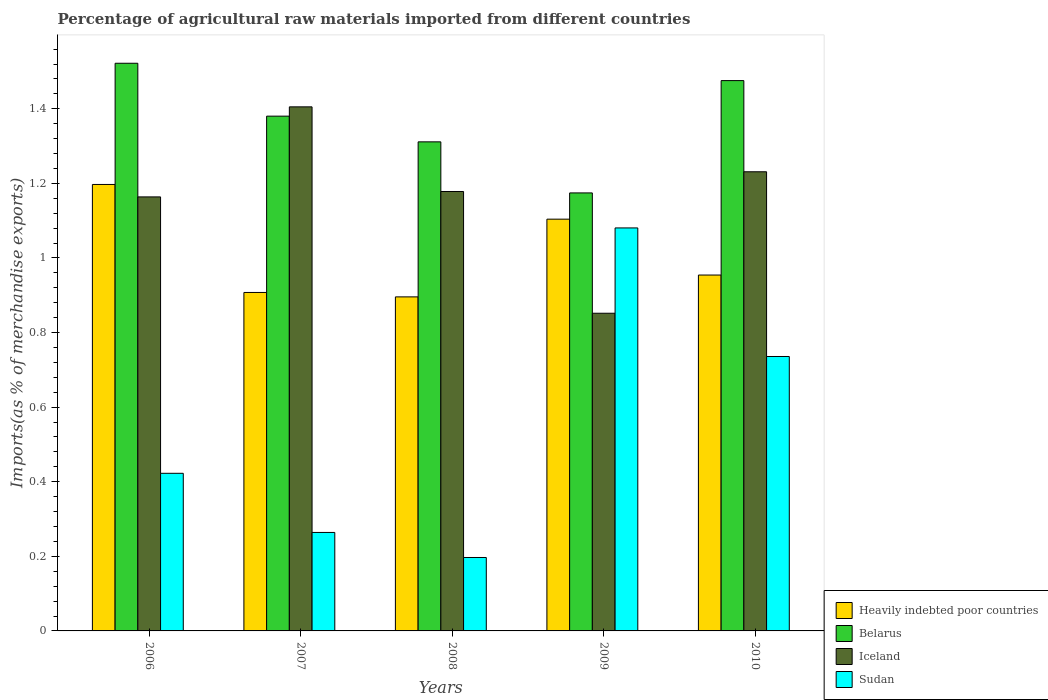How many groups of bars are there?
Offer a terse response. 5. Are the number of bars per tick equal to the number of legend labels?
Give a very brief answer. Yes. Are the number of bars on each tick of the X-axis equal?
Your response must be concise. Yes. How many bars are there on the 2nd tick from the left?
Your answer should be compact. 4. What is the percentage of imports to different countries in Sudan in 2007?
Your answer should be very brief. 0.26. Across all years, what is the maximum percentage of imports to different countries in Sudan?
Give a very brief answer. 1.08. Across all years, what is the minimum percentage of imports to different countries in Sudan?
Give a very brief answer. 0.2. In which year was the percentage of imports to different countries in Sudan maximum?
Provide a short and direct response. 2009. What is the total percentage of imports to different countries in Iceland in the graph?
Keep it short and to the point. 5.83. What is the difference between the percentage of imports to different countries in Belarus in 2006 and that in 2009?
Provide a succinct answer. 0.35. What is the difference between the percentage of imports to different countries in Belarus in 2007 and the percentage of imports to different countries in Iceland in 2006?
Provide a short and direct response. 0.22. What is the average percentage of imports to different countries in Belarus per year?
Provide a short and direct response. 1.37. In the year 2009, what is the difference between the percentage of imports to different countries in Belarus and percentage of imports to different countries in Heavily indebted poor countries?
Offer a very short reply. 0.07. What is the ratio of the percentage of imports to different countries in Belarus in 2008 to that in 2009?
Provide a short and direct response. 1.12. Is the difference between the percentage of imports to different countries in Belarus in 2007 and 2009 greater than the difference between the percentage of imports to different countries in Heavily indebted poor countries in 2007 and 2009?
Ensure brevity in your answer.  Yes. What is the difference between the highest and the second highest percentage of imports to different countries in Iceland?
Give a very brief answer. 0.17. What is the difference between the highest and the lowest percentage of imports to different countries in Sudan?
Keep it short and to the point. 0.88. In how many years, is the percentage of imports to different countries in Sudan greater than the average percentage of imports to different countries in Sudan taken over all years?
Offer a very short reply. 2. Is the sum of the percentage of imports to different countries in Heavily indebted poor countries in 2008 and 2009 greater than the maximum percentage of imports to different countries in Sudan across all years?
Keep it short and to the point. Yes. Is it the case that in every year, the sum of the percentage of imports to different countries in Belarus and percentage of imports to different countries in Iceland is greater than the sum of percentage of imports to different countries in Heavily indebted poor countries and percentage of imports to different countries in Sudan?
Your answer should be very brief. Yes. What does the 2nd bar from the left in 2008 represents?
Your answer should be very brief. Belarus. What does the 4th bar from the right in 2009 represents?
Your answer should be compact. Heavily indebted poor countries. How many years are there in the graph?
Provide a short and direct response. 5. What is the difference between two consecutive major ticks on the Y-axis?
Keep it short and to the point. 0.2. Does the graph contain any zero values?
Provide a succinct answer. No. How many legend labels are there?
Give a very brief answer. 4. How are the legend labels stacked?
Provide a short and direct response. Vertical. What is the title of the graph?
Keep it short and to the point. Percentage of agricultural raw materials imported from different countries. Does "Kyrgyz Republic" appear as one of the legend labels in the graph?
Your answer should be compact. No. What is the label or title of the X-axis?
Your response must be concise. Years. What is the label or title of the Y-axis?
Provide a succinct answer. Imports(as % of merchandise exports). What is the Imports(as % of merchandise exports) of Heavily indebted poor countries in 2006?
Your response must be concise. 1.2. What is the Imports(as % of merchandise exports) of Belarus in 2006?
Make the answer very short. 1.52. What is the Imports(as % of merchandise exports) of Iceland in 2006?
Provide a short and direct response. 1.16. What is the Imports(as % of merchandise exports) of Sudan in 2006?
Ensure brevity in your answer.  0.42. What is the Imports(as % of merchandise exports) in Heavily indebted poor countries in 2007?
Ensure brevity in your answer.  0.91. What is the Imports(as % of merchandise exports) of Belarus in 2007?
Keep it short and to the point. 1.38. What is the Imports(as % of merchandise exports) in Iceland in 2007?
Give a very brief answer. 1.41. What is the Imports(as % of merchandise exports) in Sudan in 2007?
Ensure brevity in your answer.  0.26. What is the Imports(as % of merchandise exports) in Heavily indebted poor countries in 2008?
Keep it short and to the point. 0.9. What is the Imports(as % of merchandise exports) in Belarus in 2008?
Provide a short and direct response. 1.31. What is the Imports(as % of merchandise exports) of Iceland in 2008?
Offer a terse response. 1.18. What is the Imports(as % of merchandise exports) in Sudan in 2008?
Your answer should be compact. 0.2. What is the Imports(as % of merchandise exports) of Heavily indebted poor countries in 2009?
Your answer should be very brief. 1.1. What is the Imports(as % of merchandise exports) in Belarus in 2009?
Your response must be concise. 1.17. What is the Imports(as % of merchandise exports) of Iceland in 2009?
Give a very brief answer. 0.85. What is the Imports(as % of merchandise exports) of Sudan in 2009?
Your response must be concise. 1.08. What is the Imports(as % of merchandise exports) of Heavily indebted poor countries in 2010?
Offer a terse response. 0.95. What is the Imports(as % of merchandise exports) of Belarus in 2010?
Offer a very short reply. 1.48. What is the Imports(as % of merchandise exports) of Iceland in 2010?
Provide a succinct answer. 1.23. What is the Imports(as % of merchandise exports) of Sudan in 2010?
Keep it short and to the point. 0.74. Across all years, what is the maximum Imports(as % of merchandise exports) in Heavily indebted poor countries?
Offer a very short reply. 1.2. Across all years, what is the maximum Imports(as % of merchandise exports) in Belarus?
Your response must be concise. 1.52. Across all years, what is the maximum Imports(as % of merchandise exports) of Iceland?
Your answer should be very brief. 1.41. Across all years, what is the maximum Imports(as % of merchandise exports) in Sudan?
Offer a very short reply. 1.08. Across all years, what is the minimum Imports(as % of merchandise exports) in Heavily indebted poor countries?
Ensure brevity in your answer.  0.9. Across all years, what is the minimum Imports(as % of merchandise exports) of Belarus?
Your answer should be very brief. 1.17. Across all years, what is the minimum Imports(as % of merchandise exports) of Iceland?
Give a very brief answer. 0.85. Across all years, what is the minimum Imports(as % of merchandise exports) in Sudan?
Give a very brief answer. 0.2. What is the total Imports(as % of merchandise exports) of Heavily indebted poor countries in the graph?
Provide a succinct answer. 5.06. What is the total Imports(as % of merchandise exports) of Belarus in the graph?
Give a very brief answer. 6.86. What is the total Imports(as % of merchandise exports) of Iceland in the graph?
Give a very brief answer. 5.83. What is the total Imports(as % of merchandise exports) in Sudan in the graph?
Provide a short and direct response. 2.7. What is the difference between the Imports(as % of merchandise exports) of Heavily indebted poor countries in 2006 and that in 2007?
Your response must be concise. 0.29. What is the difference between the Imports(as % of merchandise exports) in Belarus in 2006 and that in 2007?
Offer a very short reply. 0.14. What is the difference between the Imports(as % of merchandise exports) of Iceland in 2006 and that in 2007?
Ensure brevity in your answer.  -0.24. What is the difference between the Imports(as % of merchandise exports) in Sudan in 2006 and that in 2007?
Your answer should be very brief. 0.16. What is the difference between the Imports(as % of merchandise exports) in Heavily indebted poor countries in 2006 and that in 2008?
Your answer should be compact. 0.3. What is the difference between the Imports(as % of merchandise exports) in Belarus in 2006 and that in 2008?
Offer a terse response. 0.21. What is the difference between the Imports(as % of merchandise exports) in Iceland in 2006 and that in 2008?
Make the answer very short. -0.01. What is the difference between the Imports(as % of merchandise exports) of Sudan in 2006 and that in 2008?
Your response must be concise. 0.23. What is the difference between the Imports(as % of merchandise exports) of Heavily indebted poor countries in 2006 and that in 2009?
Your answer should be very brief. 0.09. What is the difference between the Imports(as % of merchandise exports) in Belarus in 2006 and that in 2009?
Your answer should be compact. 0.35. What is the difference between the Imports(as % of merchandise exports) of Iceland in 2006 and that in 2009?
Give a very brief answer. 0.31. What is the difference between the Imports(as % of merchandise exports) in Sudan in 2006 and that in 2009?
Ensure brevity in your answer.  -0.66. What is the difference between the Imports(as % of merchandise exports) of Heavily indebted poor countries in 2006 and that in 2010?
Ensure brevity in your answer.  0.24. What is the difference between the Imports(as % of merchandise exports) in Belarus in 2006 and that in 2010?
Your response must be concise. 0.05. What is the difference between the Imports(as % of merchandise exports) in Iceland in 2006 and that in 2010?
Make the answer very short. -0.07. What is the difference between the Imports(as % of merchandise exports) of Sudan in 2006 and that in 2010?
Ensure brevity in your answer.  -0.31. What is the difference between the Imports(as % of merchandise exports) of Heavily indebted poor countries in 2007 and that in 2008?
Provide a short and direct response. 0.01. What is the difference between the Imports(as % of merchandise exports) in Belarus in 2007 and that in 2008?
Keep it short and to the point. 0.07. What is the difference between the Imports(as % of merchandise exports) of Iceland in 2007 and that in 2008?
Make the answer very short. 0.23. What is the difference between the Imports(as % of merchandise exports) of Sudan in 2007 and that in 2008?
Provide a short and direct response. 0.07. What is the difference between the Imports(as % of merchandise exports) in Heavily indebted poor countries in 2007 and that in 2009?
Ensure brevity in your answer.  -0.2. What is the difference between the Imports(as % of merchandise exports) in Belarus in 2007 and that in 2009?
Provide a short and direct response. 0.21. What is the difference between the Imports(as % of merchandise exports) of Iceland in 2007 and that in 2009?
Your answer should be very brief. 0.55. What is the difference between the Imports(as % of merchandise exports) in Sudan in 2007 and that in 2009?
Your response must be concise. -0.82. What is the difference between the Imports(as % of merchandise exports) of Heavily indebted poor countries in 2007 and that in 2010?
Ensure brevity in your answer.  -0.05. What is the difference between the Imports(as % of merchandise exports) of Belarus in 2007 and that in 2010?
Your answer should be compact. -0.1. What is the difference between the Imports(as % of merchandise exports) of Iceland in 2007 and that in 2010?
Make the answer very short. 0.17. What is the difference between the Imports(as % of merchandise exports) of Sudan in 2007 and that in 2010?
Offer a terse response. -0.47. What is the difference between the Imports(as % of merchandise exports) of Heavily indebted poor countries in 2008 and that in 2009?
Offer a terse response. -0.21. What is the difference between the Imports(as % of merchandise exports) in Belarus in 2008 and that in 2009?
Provide a short and direct response. 0.14. What is the difference between the Imports(as % of merchandise exports) in Iceland in 2008 and that in 2009?
Keep it short and to the point. 0.33. What is the difference between the Imports(as % of merchandise exports) of Sudan in 2008 and that in 2009?
Make the answer very short. -0.88. What is the difference between the Imports(as % of merchandise exports) in Heavily indebted poor countries in 2008 and that in 2010?
Provide a succinct answer. -0.06. What is the difference between the Imports(as % of merchandise exports) in Belarus in 2008 and that in 2010?
Ensure brevity in your answer.  -0.16. What is the difference between the Imports(as % of merchandise exports) of Iceland in 2008 and that in 2010?
Offer a terse response. -0.05. What is the difference between the Imports(as % of merchandise exports) in Sudan in 2008 and that in 2010?
Make the answer very short. -0.54. What is the difference between the Imports(as % of merchandise exports) of Heavily indebted poor countries in 2009 and that in 2010?
Provide a short and direct response. 0.15. What is the difference between the Imports(as % of merchandise exports) in Belarus in 2009 and that in 2010?
Your response must be concise. -0.3. What is the difference between the Imports(as % of merchandise exports) of Iceland in 2009 and that in 2010?
Your response must be concise. -0.38. What is the difference between the Imports(as % of merchandise exports) of Sudan in 2009 and that in 2010?
Provide a succinct answer. 0.34. What is the difference between the Imports(as % of merchandise exports) of Heavily indebted poor countries in 2006 and the Imports(as % of merchandise exports) of Belarus in 2007?
Keep it short and to the point. -0.18. What is the difference between the Imports(as % of merchandise exports) in Heavily indebted poor countries in 2006 and the Imports(as % of merchandise exports) in Iceland in 2007?
Your answer should be compact. -0.21. What is the difference between the Imports(as % of merchandise exports) of Heavily indebted poor countries in 2006 and the Imports(as % of merchandise exports) of Sudan in 2007?
Provide a short and direct response. 0.93. What is the difference between the Imports(as % of merchandise exports) of Belarus in 2006 and the Imports(as % of merchandise exports) of Iceland in 2007?
Your response must be concise. 0.12. What is the difference between the Imports(as % of merchandise exports) of Belarus in 2006 and the Imports(as % of merchandise exports) of Sudan in 2007?
Give a very brief answer. 1.26. What is the difference between the Imports(as % of merchandise exports) of Iceland in 2006 and the Imports(as % of merchandise exports) of Sudan in 2007?
Make the answer very short. 0.9. What is the difference between the Imports(as % of merchandise exports) of Heavily indebted poor countries in 2006 and the Imports(as % of merchandise exports) of Belarus in 2008?
Make the answer very short. -0.11. What is the difference between the Imports(as % of merchandise exports) in Heavily indebted poor countries in 2006 and the Imports(as % of merchandise exports) in Iceland in 2008?
Your answer should be compact. 0.02. What is the difference between the Imports(as % of merchandise exports) in Belarus in 2006 and the Imports(as % of merchandise exports) in Iceland in 2008?
Provide a succinct answer. 0.34. What is the difference between the Imports(as % of merchandise exports) in Belarus in 2006 and the Imports(as % of merchandise exports) in Sudan in 2008?
Provide a succinct answer. 1.33. What is the difference between the Imports(as % of merchandise exports) in Iceland in 2006 and the Imports(as % of merchandise exports) in Sudan in 2008?
Your response must be concise. 0.97. What is the difference between the Imports(as % of merchandise exports) in Heavily indebted poor countries in 2006 and the Imports(as % of merchandise exports) in Belarus in 2009?
Your response must be concise. 0.02. What is the difference between the Imports(as % of merchandise exports) of Heavily indebted poor countries in 2006 and the Imports(as % of merchandise exports) of Iceland in 2009?
Provide a succinct answer. 0.35. What is the difference between the Imports(as % of merchandise exports) in Heavily indebted poor countries in 2006 and the Imports(as % of merchandise exports) in Sudan in 2009?
Keep it short and to the point. 0.12. What is the difference between the Imports(as % of merchandise exports) of Belarus in 2006 and the Imports(as % of merchandise exports) of Iceland in 2009?
Provide a succinct answer. 0.67. What is the difference between the Imports(as % of merchandise exports) of Belarus in 2006 and the Imports(as % of merchandise exports) of Sudan in 2009?
Your response must be concise. 0.44. What is the difference between the Imports(as % of merchandise exports) of Iceland in 2006 and the Imports(as % of merchandise exports) of Sudan in 2009?
Provide a short and direct response. 0.08. What is the difference between the Imports(as % of merchandise exports) in Heavily indebted poor countries in 2006 and the Imports(as % of merchandise exports) in Belarus in 2010?
Make the answer very short. -0.28. What is the difference between the Imports(as % of merchandise exports) of Heavily indebted poor countries in 2006 and the Imports(as % of merchandise exports) of Iceland in 2010?
Make the answer very short. -0.03. What is the difference between the Imports(as % of merchandise exports) in Heavily indebted poor countries in 2006 and the Imports(as % of merchandise exports) in Sudan in 2010?
Your answer should be compact. 0.46. What is the difference between the Imports(as % of merchandise exports) in Belarus in 2006 and the Imports(as % of merchandise exports) in Iceland in 2010?
Ensure brevity in your answer.  0.29. What is the difference between the Imports(as % of merchandise exports) of Belarus in 2006 and the Imports(as % of merchandise exports) of Sudan in 2010?
Your response must be concise. 0.79. What is the difference between the Imports(as % of merchandise exports) in Iceland in 2006 and the Imports(as % of merchandise exports) in Sudan in 2010?
Your response must be concise. 0.43. What is the difference between the Imports(as % of merchandise exports) in Heavily indebted poor countries in 2007 and the Imports(as % of merchandise exports) in Belarus in 2008?
Make the answer very short. -0.4. What is the difference between the Imports(as % of merchandise exports) in Heavily indebted poor countries in 2007 and the Imports(as % of merchandise exports) in Iceland in 2008?
Keep it short and to the point. -0.27. What is the difference between the Imports(as % of merchandise exports) of Heavily indebted poor countries in 2007 and the Imports(as % of merchandise exports) of Sudan in 2008?
Offer a very short reply. 0.71. What is the difference between the Imports(as % of merchandise exports) of Belarus in 2007 and the Imports(as % of merchandise exports) of Iceland in 2008?
Ensure brevity in your answer.  0.2. What is the difference between the Imports(as % of merchandise exports) in Belarus in 2007 and the Imports(as % of merchandise exports) in Sudan in 2008?
Offer a terse response. 1.18. What is the difference between the Imports(as % of merchandise exports) in Iceland in 2007 and the Imports(as % of merchandise exports) in Sudan in 2008?
Provide a short and direct response. 1.21. What is the difference between the Imports(as % of merchandise exports) of Heavily indebted poor countries in 2007 and the Imports(as % of merchandise exports) of Belarus in 2009?
Offer a terse response. -0.27. What is the difference between the Imports(as % of merchandise exports) of Heavily indebted poor countries in 2007 and the Imports(as % of merchandise exports) of Iceland in 2009?
Give a very brief answer. 0.06. What is the difference between the Imports(as % of merchandise exports) in Heavily indebted poor countries in 2007 and the Imports(as % of merchandise exports) in Sudan in 2009?
Give a very brief answer. -0.17. What is the difference between the Imports(as % of merchandise exports) of Belarus in 2007 and the Imports(as % of merchandise exports) of Iceland in 2009?
Offer a very short reply. 0.53. What is the difference between the Imports(as % of merchandise exports) in Belarus in 2007 and the Imports(as % of merchandise exports) in Sudan in 2009?
Keep it short and to the point. 0.3. What is the difference between the Imports(as % of merchandise exports) in Iceland in 2007 and the Imports(as % of merchandise exports) in Sudan in 2009?
Your answer should be compact. 0.32. What is the difference between the Imports(as % of merchandise exports) in Heavily indebted poor countries in 2007 and the Imports(as % of merchandise exports) in Belarus in 2010?
Offer a very short reply. -0.57. What is the difference between the Imports(as % of merchandise exports) of Heavily indebted poor countries in 2007 and the Imports(as % of merchandise exports) of Iceland in 2010?
Keep it short and to the point. -0.32. What is the difference between the Imports(as % of merchandise exports) of Heavily indebted poor countries in 2007 and the Imports(as % of merchandise exports) of Sudan in 2010?
Offer a terse response. 0.17. What is the difference between the Imports(as % of merchandise exports) of Belarus in 2007 and the Imports(as % of merchandise exports) of Iceland in 2010?
Offer a terse response. 0.15. What is the difference between the Imports(as % of merchandise exports) of Belarus in 2007 and the Imports(as % of merchandise exports) of Sudan in 2010?
Give a very brief answer. 0.64. What is the difference between the Imports(as % of merchandise exports) in Iceland in 2007 and the Imports(as % of merchandise exports) in Sudan in 2010?
Keep it short and to the point. 0.67. What is the difference between the Imports(as % of merchandise exports) of Heavily indebted poor countries in 2008 and the Imports(as % of merchandise exports) of Belarus in 2009?
Keep it short and to the point. -0.28. What is the difference between the Imports(as % of merchandise exports) of Heavily indebted poor countries in 2008 and the Imports(as % of merchandise exports) of Iceland in 2009?
Offer a terse response. 0.04. What is the difference between the Imports(as % of merchandise exports) in Heavily indebted poor countries in 2008 and the Imports(as % of merchandise exports) in Sudan in 2009?
Offer a terse response. -0.18. What is the difference between the Imports(as % of merchandise exports) of Belarus in 2008 and the Imports(as % of merchandise exports) of Iceland in 2009?
Offer a terse response. 0.46. What is the difference between the Imports(as % of merchandise exports) in Belarus in 2008 and the Imports(as % of merchandise exports) in Sudan in 2009?
Give a very brief answer. 0.23. What is the difference between the Imports(as % of merchandise exports) in Iceland in 2008 and the Imports(as % of merchandise exports) in Sudan in 2009?
Give a very brief answer. 0.1. What is the difference between the Imports(as % of merchandise exports) of Heavily indebted poor countries in 2008 and the Imports(as % of merchandise exports) of Belarus in 2010?
Make the answer very short. -0.58. What is the difference between the Imports(as % of merchandise exports) of Heavily indebted poor countries in 2008 and the Imports(as % of merchandise exports) of Iceland in 2010?
Offer a very short reply. -0.34. What is the difference between the Imports(as % of merchandise exports) in Heavily indebted poor countries in 2008 and the Imports(as % of merchandise exports) in Sudan in 2010?
Offer a very short reply. 0.16. What is the difference between the Imports(as % of merchandise exports) in Belarus in 2008 and the Imports(as % of merchandise exports) in Iceland in 2010?
Keep it short and to the point. 0.08. What is the difference between the Imports(as % of merchandise exports) in Belarus in 2008 and the Imports(as % of merchandise exports) in Sudan in 2010?
Give a very brief answer. 0.58. What is the difference between the Imports(as % of merchandise exports) of Iceland in 2008 and the Imports(as % of merchandise exports) of Sudan in 2010?
Give a very brief answer. 0.44. What is the difference between the Imports(as % of merchandise exports) of Heavily indebted poor countries in 2009 and the Imports(as % of merchandise exports) of Belarus in 2010?
Keep it short and to the point. -0.37. What is the difference between the Imports(as % of merchandise exports) of Heavily indebted poor countries in 2009 and the Imports(as % of merchandise exports) of Iceland in 2010?
Your answer should be very brief. -0.13. What is the difference between the Imports(as % of merchandise exports) of Heavily indebted poor countries in 2009 and the Imports(as % of merchandise exports) of Sudan in 2010?
Your response must be concise. 0.37. What is the difference between the Imports(as % of merchandise exports) of Belarus in 2009 and the Imports(as % of merchandise exports) of Iceland in 2010?
Offer a terse response. -0.06. What is the difference between the Imports(as % of merchandise exports) of Belarus in 2009 and the Imports(as % of merchandise exports) of Sudan in 2010?
Your response must be concise. 0.44. What is the difference between the Imports(as % of merchandise exports) in Iceland in 2009 and the Imports(as % of merchandise exports) in Sudan in 2010?
Your answer should be very brief. 0.12. What is the average Imports(as % of merchandise exports) in Heavily indebted poor countries per year?
Your response must be concise. 1.01. What is the average Imports(as % of merchandise exports) in Belarus per year?
Your answer should be compact. 1.37. What is the average Imports(as % of merchandise exports) of Iceland per year?
Ensure brevity in your answer.  1.17. What is the average Imports(as % of merchandise exports) of Sudan per year?
Make the answer very short. 0.54. In the year 2006, what is the difference between the Imports(as % of merchandise exports) in Heavily indebted poor countries and Imports(as % of merchandise exports) in Belarus?
Provide a succinct answer. -0.32. In the year 2006, what is the difference between the Imports(as % of merchandise exports) in Heavily indebted poor countries and Imports(as % of merchandise exports) in Iceland?
Make the answer very short. 0.03. In the year 2006, what is the difference between the Imports(as % of merchandise exports) of Heavily indebted poor countries and Imports(as % of merchandise exports) of Sudan?
Provide a short and direct response. 0.77. In the year 2006, what is the difference between the Imports(as % of merchandise exports) of Belarus and Imports(as % of merchandise exports) of Iceland?
Provide a succinct answer. 0.36. In the year 2006, what is the difference between the Imports(as % of merchandise exports) of Belarus and Imports(as % of merchandise exports) of Sudan?
Your answer should be very brief. 1.1. In the year 2006, what is the difference between the Imports(as % of merchandise exports) of Iceland and Imports(as % of merchandise exports) of Sudan?
Your answer should be very brief. 0.74. In the year 2007, what is the difference between the Imports(as % of merchandise exports) in Heavily indebted poor countries and Imports(as % of merchandise exports) in Belarus?
Make the answer very short. -0.47. In the year 2007, what is the difference between the Imports(as % of merchandise exports) in Heavily indebted poor countries and Imports(as % of merchandise exports) in Iceland?
Make the answer very short. -0.5. In the year 2007, what is the difference between the Imports(as % of merchandise exports) of Heavily indebted poor countries and Imports(as % of merchandise exports) of Sudan?
Make the answer very short. 0.64. In the year 2007, what is the difference between the Imports(as % of merchandise exports) of Belarus and Imports(as % of merchandise exports) of Iceland?
Give a very brief answer. -0.02. In the year 2007, what is the difference between the Imports(as % of merchandise exports) of Belarus and Imports(as % of merchandise exports) of Sudan?
Your answer should be compact. 1.12. In the year 2007, what is the difference between the Imports(as % of merchandise exports) of Iceland and Imports(as % of merchandise exports) of Sudan?
Keep it short and to the point. 1.14. In the year 2008, what is the difference between the Imports(as % of merchandise exports) in Heavily indebted poor countries and Imports(as % of merchandise exports) in Belarus?
Keep it short and to the point. -0.42. In the year 2008, what is the difference between the Imports(as % of merchandise exports) in Heavily indebted poor countries and Imports(as % of merchandise exports) in Iceland?
Your response must be concise. -0.28. In the year 2008, what is the difference between the Imports(as % of merchandise exports) in Heavily indebted poor countries and Imports(as % of merchandise exports) in Sudan?
Make the answer very short. 0.7. In the year 2008, what is the difference between the Imports(as % of merchandise exports) of Belarus and Imports(as % of merchandise exports) of Iceland?
Your answer should be compact. 0.13. In the year 2008, what is the difference between the Imports(as % of merchandise exports) of Belarus and Imports(as % of merchandise exports) of Sudan?
Make the answer very short. 1.11. In the year 2008, what is the difference between the Imports(as % of merchandise exports) of Iceland and Imports(as % of merchandise exports) of Sudan?
Ensure brevity in your answer.  0.98. In the year 2009, what is the difference between the Imports(as % of merchandise exports) in Heavily indebted poor countries and Imports(as % of merchandise exports) in Belarus?
Offer a terse response. -0.07. In the year 2009, what is the difference between the Imports(as % of merchandise exports) in Heavily indebted poor countries and Imports(as % of merchandise exports) in Iceland?
Give a very brief answer. 0.25. In the year 2009, what is the difference between the Imports(as % of merchandise exports) of Heavily indebted poor countries and Imports(as % of merchandise exports) of Sudan?
Provide a short and direct response. 0.02. In the year 2009, what is the difference between the Imports(as % of merchandise exports) of Belarus and Imports(as % of merchandise exports) of Iceland?
Your response must be concise. 0.32. In the year 2009, what is the difference between the Imports(as % of merchandise exports) in Belarus and Imports(as % of merchandise exports) in Sudan?
Keep it short and to the point. 0.09. In the year 2009, what is the difference between the Imports(as % of merchandise exports) of Iceland and Imports(as % of merchandise exports) of Sudan?
Your response must be concise. -0.23. In the year 2010, what is the difference between the Imports(as % of merchandise exports) in Heavily indebted poor countries and Imports(as % of merchandise exports) in Belarus?
Your answer should be compact. -0.52. In the year 2010, what is the difference between the Imports(as % of merchandise exports) of Heavily indebted poor countries and Imports(as % of merchandise exports) of Iceland?
Keep it short and to the point. -0.28. In the year 2010, what is the difference between the Imports(as % of merchandise exports) in Heavily indebted poor countries and Imports(as % of merchandise exports) in Sudan?
Your answer should be compact. 0.22. In the year 2010, what is the difference between the Imports(as % of merchandise exports) in Belarus and Imports(as % of merchandise exports) in Iceland?
Offer a terse response. 0.24. In the year 2010, what is the difference between the Imports(as % of merchandise exports) in Belarus and Imports(as % of merchandise exports) in Sudan?
Ensure brevity in your answer.  0.74. In the year 2010, what is the difference between the Imports(as % of merchandise exports) in Iceland and Imports(as % of merchandise exports) in Sudan?
Your response must be concise. 0.5. What is the ratio of the Imports(as % of merchandise exports) in Heavily indebted poor countries in 2006 to that in 2007?
Ensure brevity in your answer.  1.32. What is the ratio of the Imports(as % of merchandise exports) in Belarus in 2006 to that in 2007?
Your answer should be compact. 1.1. What is the ratio of the Imports(as % of merchandise exports) of Iceland in 2006 to that in 2007?
Your response must be concise. 0.83. What is the ratio of the Imports(as % of merchandise exports) of Sudan in 2006 to that in 2007?
Provide a short and direct response. 1.6. What is the ratio of the Imports(as % of merchandise exports) in Heavily indebted poor countries in 2006 to that in 2008?
Your answer should be compact. 1.34. What is the ratio of the Imports(as % of merchandise exports) in Belarus in 2006 to that in 2008?
Provide a short and direct response. 1.16. What is the ratio of the Imports(as % of merchandise exports) in Iceland in 2006 to that in 2008?
Offer a terse response. 0.99. What is the ratio of the Imports(as % of merchandise exports) of Sudan in 2006 to that in 2008?
Give a very brief answer. 2.15. What is the ratio of the Imports(as % of merchandise exports) of Heavily indebted poor countries in 2006 to that in 2009?
Provide a short and direct response. 1.08. What is the ratio of the Imports(as % of merchandise exports) in Belarus in 2006 to that in 2009?
Provide a short and direct response. 1.3. What is the ratio of the Imports(as % of merchandise exports) in Iceland in 2006 to that in 2009?
Make the answer very short. 1.37. What is the ratio of the Imports(as % of merchandise exports) of Sudan in 2006 to that in 2009?
Keep it short and to the point. 0.39. What is the ratio of the Imports(as % of merchandise exports) in Heavily indebted poor countries in 2006 to that in 2010?
Ensure brevity in your answer.  1.25. What is the ratio of the Imports(as % of merchandise exports) of Belarus in 2006 to that in 2010?
Your answer should be very brief. 1.03. What is the ratio of the Imports(as % of merchandise exports) of Iceland in 2006 to that in 2010?
Keep it short and to the point. 0.95. What is the ratio of the Imports(as % of merchandise exports) of Sudan in 2006 to that in 2010?
Provide a short and direct response. 0.57. What is the ratio of the Imports(as % of merchandise exports) in Heavily indebted poor countries in 2007 to that in 2008?
Your answer should be compact. 1.01. What is the ratio of the Imports(as % of merchandise exports) of Belarus in 2007 to that in 2008?
Offer a terse response. 1.05. What is the ratio of the Imports(as % of merchandise exports) of Iceland in 2007 to that in 2008?
Your answer should be very brief. 1.19. What is the ratio of the Imports(as % of merchandise exports) of Sudan in 2007 to that in 2008?
Offer a terse response. 1.34. What is the ratio of the Imports(as % of merchandise exports) in Heavily indebted poor countries in 2007 to that in 2009?
Provide a succinct answer. 0.82. What is the ratio of the Imports(as % of merchandise exports) in Belarus in 2007 to that in 2009?
Ensure brevity in your answer.  1.18. What is the ratio of the Imports(as % of merchandise exports) of Iceland in 2007 to that in 2009?
Make the answer very short. 1.65. What is the ratio of the Imports(as % of merchandise exports) of Sudan in 2007 to that in 2009?
Keep it short and to the point. 0.24. What is the ratio of the Imports(as % of merchandise exports) in Heavily indebted poor countries in 2007 to that in 2010?
Offer a terse response. 0.95. What is the ratio of the Imports(as % of merchandise exports) of Belarus in 2007 to that in 2010?
Provide a succinct answer. 0.94. What is the ratio of the Imports(as % of merchandise exports) of Iceland in 2007 to that in 2010?
Your response must be concise. 1.14. What is the ratio of the Imports(as % of merchandise exports) in Sudan in 2007 to that in 2010?
Your response must be concise. 0.36. What is the ratio of the Imports(as % of merchandise exports) in Heavily indebted poor countries in 2008 to that in 2009?
Your response must be concise. 0.81. What is the ratio of the Imports(as % of merchandise exports) in Belarus in 2008 to that in 2009?
Provide a succinct answer. 1.12. What is the ratio of the Imports(as % of merchandise exports) of Iceland in 2008 to that in 2009?
Give a very brief answer. 1.38. What is the ratio of the Imports(as % of merchandise exports) of Sudan in 2008 to that in 2009?
Give a very brief answer. 0.18. What is the ratio of the Imports(as % of merchandise exports) in Heavily indebted poor countries in 2008 to that in 2010?
Provide a succinct answer. 0.94. What is the ratio of the Imports(as % of merchandise exports) of Belarus in 2008 to that in 2010?
Ensure brevity in your answer.  0.89. What is the ratio of the Imports(as % of merchandise exports) of Sudan in 2008 to that in 2010?
Provide a succinct answer. 0.27. What is the ratio of the Imports(as % of merchandise exports) in Heavily indebted poor countries in 2009 to that in 2010?
Provide a succinct answer. 1.16. What is the ratio of the Imports(as % of merchandise exports) in Belarus in 2009 to that in 2010?
Keep it short and to the point. 0.8. What is the ratio of the Imports(as % of merchandise exports) in Iceland in 2009 to that in 2010?
Offer a very short reply. 0.69. What is the ratio of the Imports(as % of merchandise exports) of Sudan in 2009 to that in 2010?
Make the answer very short. 1.47. What is the difference between the highest and the second highest Imports(as % of merchandise exports) in Heavily indebted poor countries?
Provide a succinct answer. 0.09. What is the difference between the highest and the second highest Imports(as % of merchandise exports) in Belarus?
Offer a terse response. 0.05. What is the difference between the highest and the second highest Imports(as % of merchandise exports) of Iceland?
Provide a short and direct response. 0.17. What is the difference between the highest and the second highest Imports(as % of merchandise exports) in Sudan?
Offer a very short reply. 0.34. What is the difference between the highest and the lowest Imports(as % of merchandise exports) of Heavily indebted poor countries?
Offer a very short reply. 0.3. What is the difference between the highest and the lowest Imports(as % of merchandise exports) of Belarus?
Give a very brief answer. 0.35. What is the difference between the highest and the lowest Imports(as % of merchandise exports) in Iceland?
Give a very brief answer. 0.55. What is the difference between the highest and the lowest Imports(as % of merchandise exports) in Sudan?
Keep it short and to the point. 0.88. 